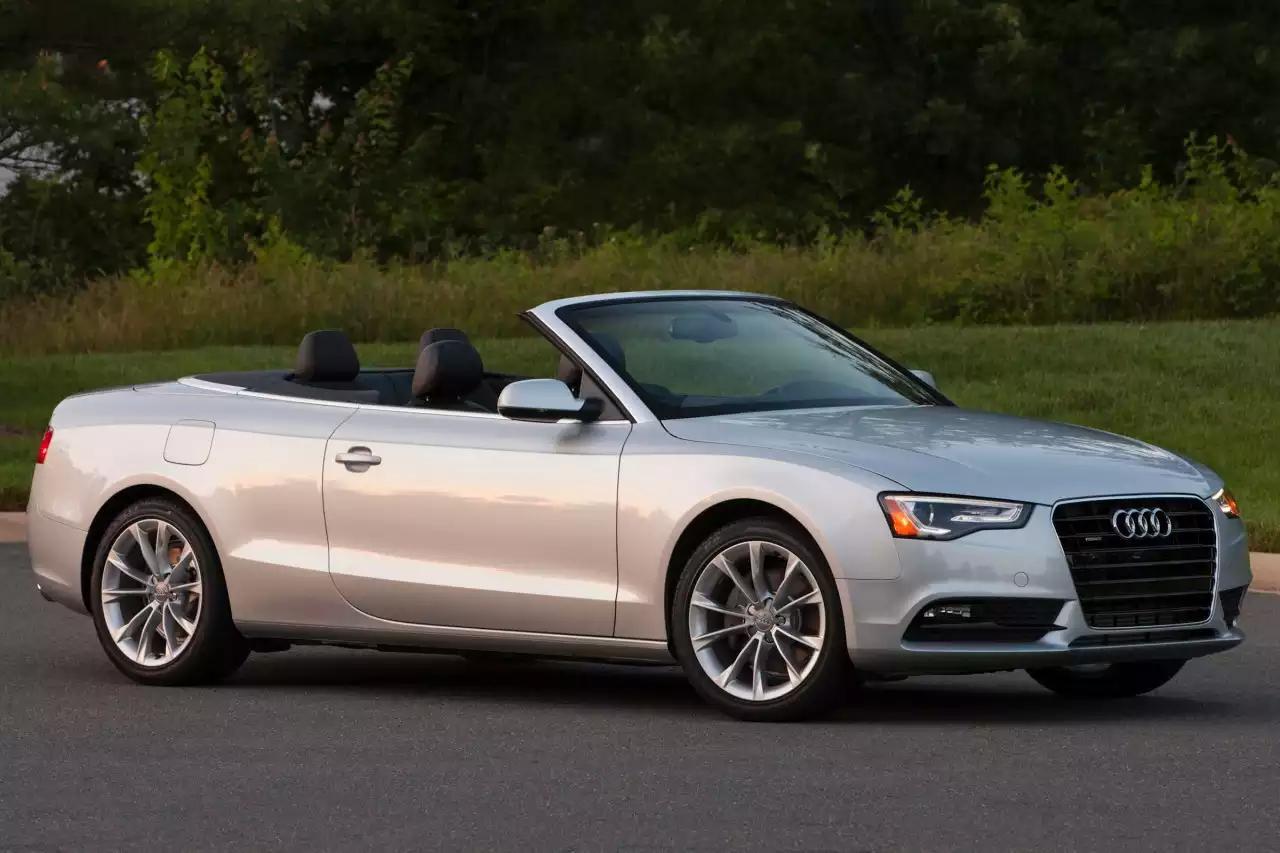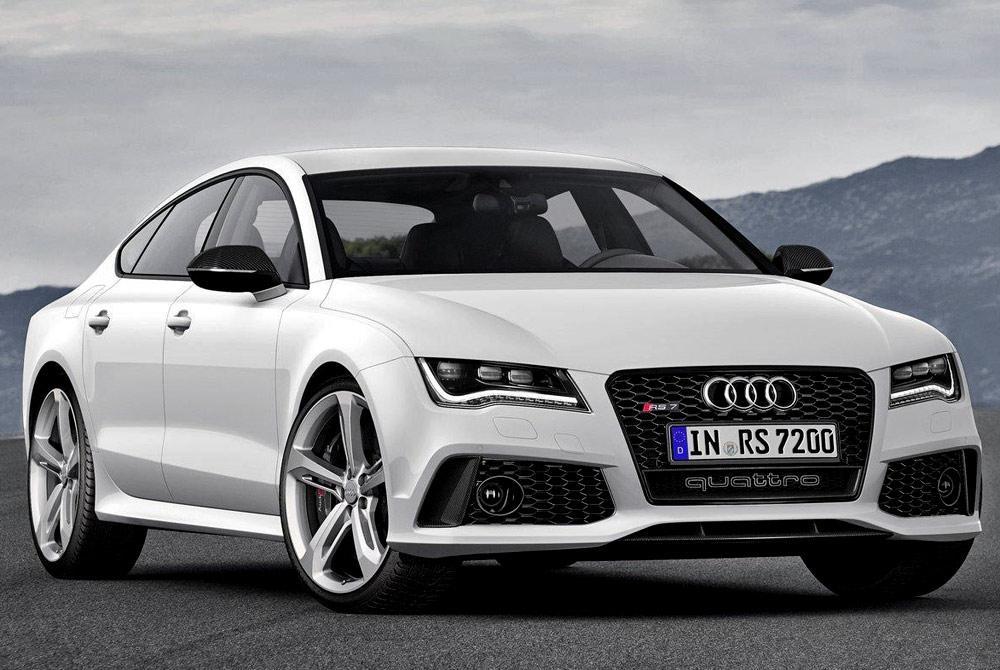The first image is the image on the left, the second image is the image on the right. For the images shown, is this caption "The combined images include a topless white convertible with its rear to the camera moving leftward, and a topless convertible facing forward." true? Answer yes or no. No. The first image is the image on the left, the second image is the image on the right. For the images shown, is this caption "There is at least one car facing towards the right side." true? Answer yes or no. Yes. 